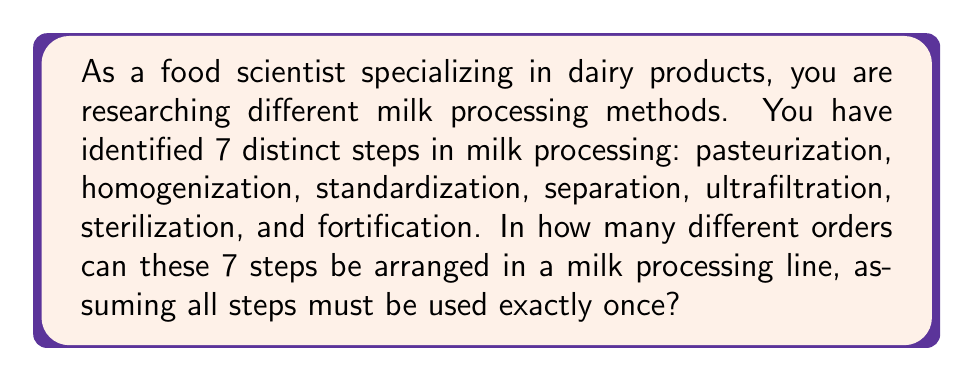Teach me how to tackle this problem. To solve this problem, we need to calculate the number of permutations of 7 distinct items. This is a classic permutation problem where the order matters and each item is used exactly once.

The formula for permutations of n distinct objects is:

$$P(n) = n!$$

Where $n!$ represents the factorial of n.

In this case, we have 7 distinct processing steps, so $n = 7$.

Therefore, we need to calculate:

$$P(7) = 7!$$

Let's expand this:

$$7! = 7 \times 6 \times 5 \times 4 \times 3 \times 2 \times 1$$

Multiplying these numbers:

$$7! = 5040$$

This means there are 5040 different ways to arrange the 7 milk processing steps.

Each of these arrangements represents a unique order in which the milk could be processed, potentially resulting in different nutritional or physical properties of the final product. As a food scientist, understanding these permutations could be crucial for experimenting with new processing techniques or optimizing existing ones for better nutritional outcomes.
Answer: $5040$ 